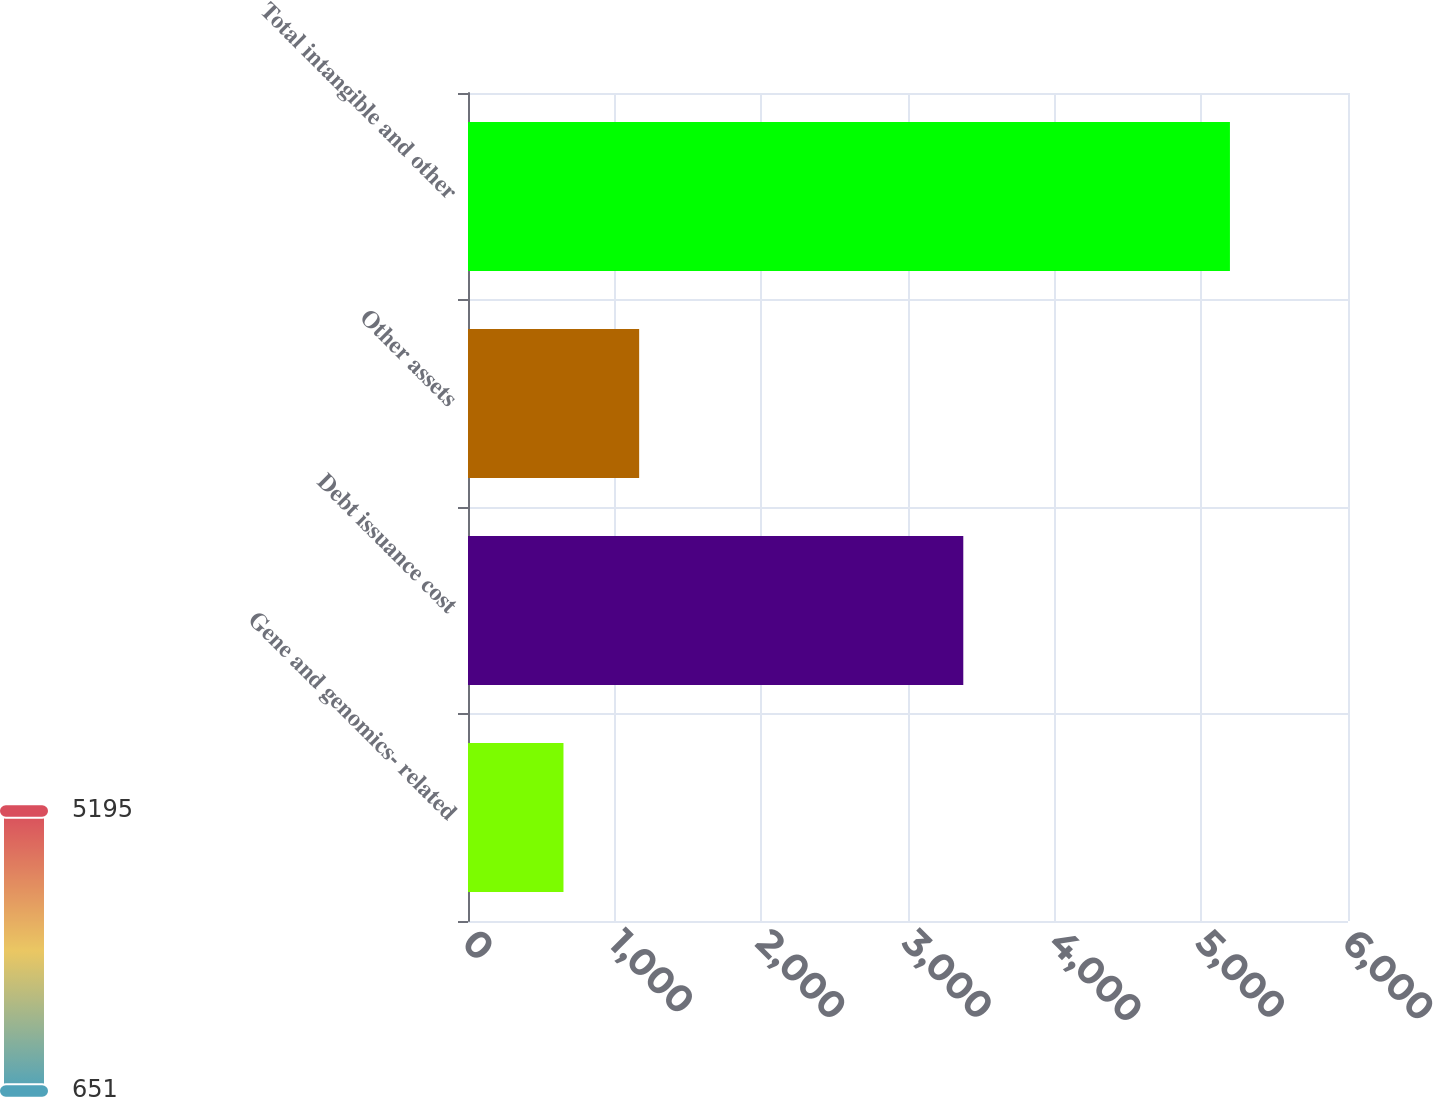Convert chart. <chart><loc_0><loc_0><loc_500><loc_500><bar_chart><fcel>Gene and genomics- related<fcel>Debt issuance cost<fcel>Other assets<fcel>Total intangible and other<nl><fcel>651<fcel>3377<fcel>1167<fcel>5195<nl></chart> 